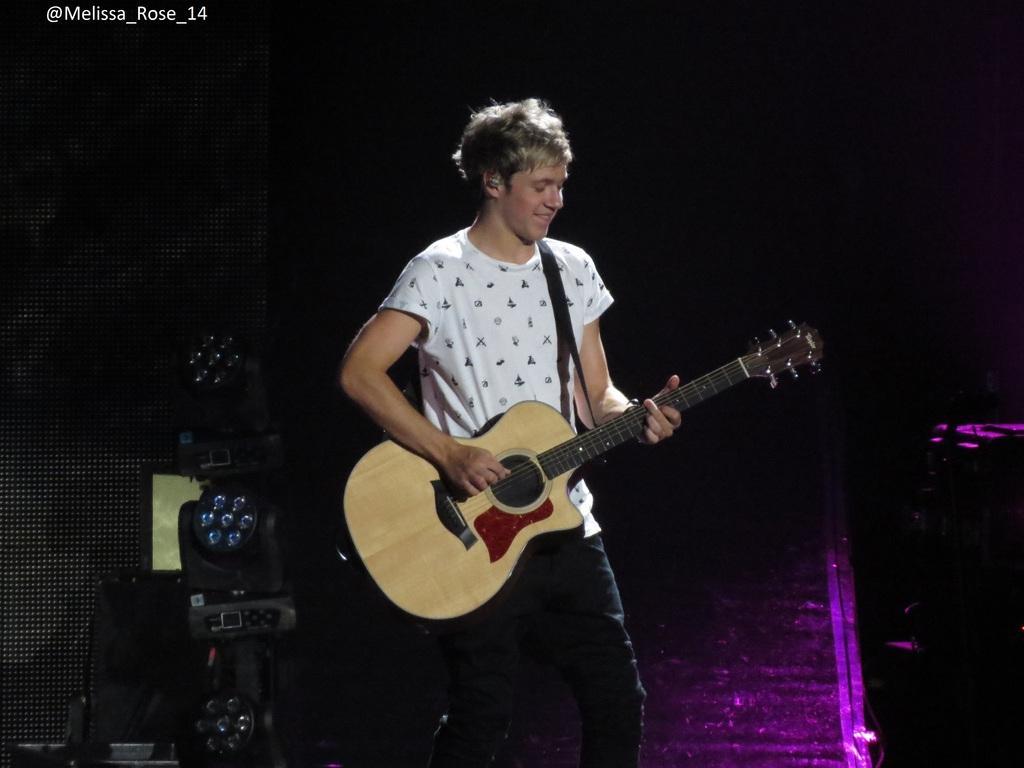In one or two sentences, can you explain what this image depicts? This is a picture of a concert. In the center of the picture there is a man in white t-shirt standing and playing guitar. On the left there are speakers and focus light. Background is dark. 